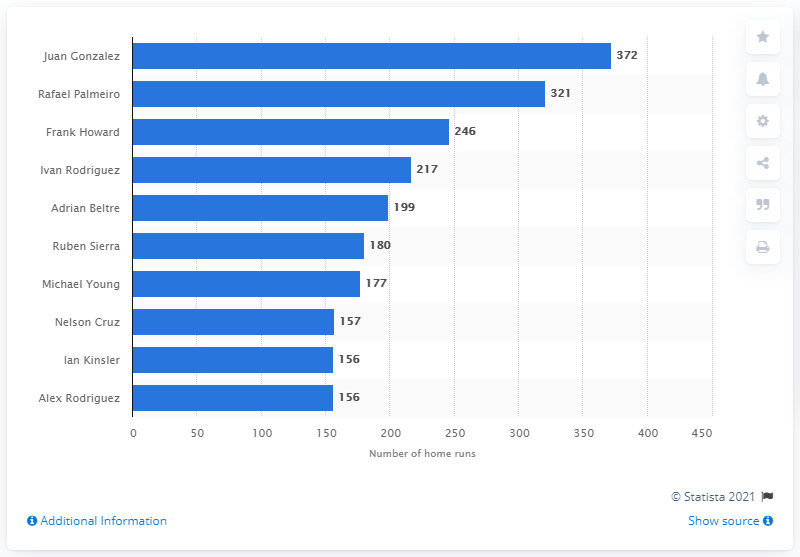Point out several critical features in this image. Juan Gonzalez is the Texas Rangers franchise history's all-time home run leader, having hit the most home runs out of all players who have played for the Rangers. Juan Gonzalez has hit 372 home runs. 